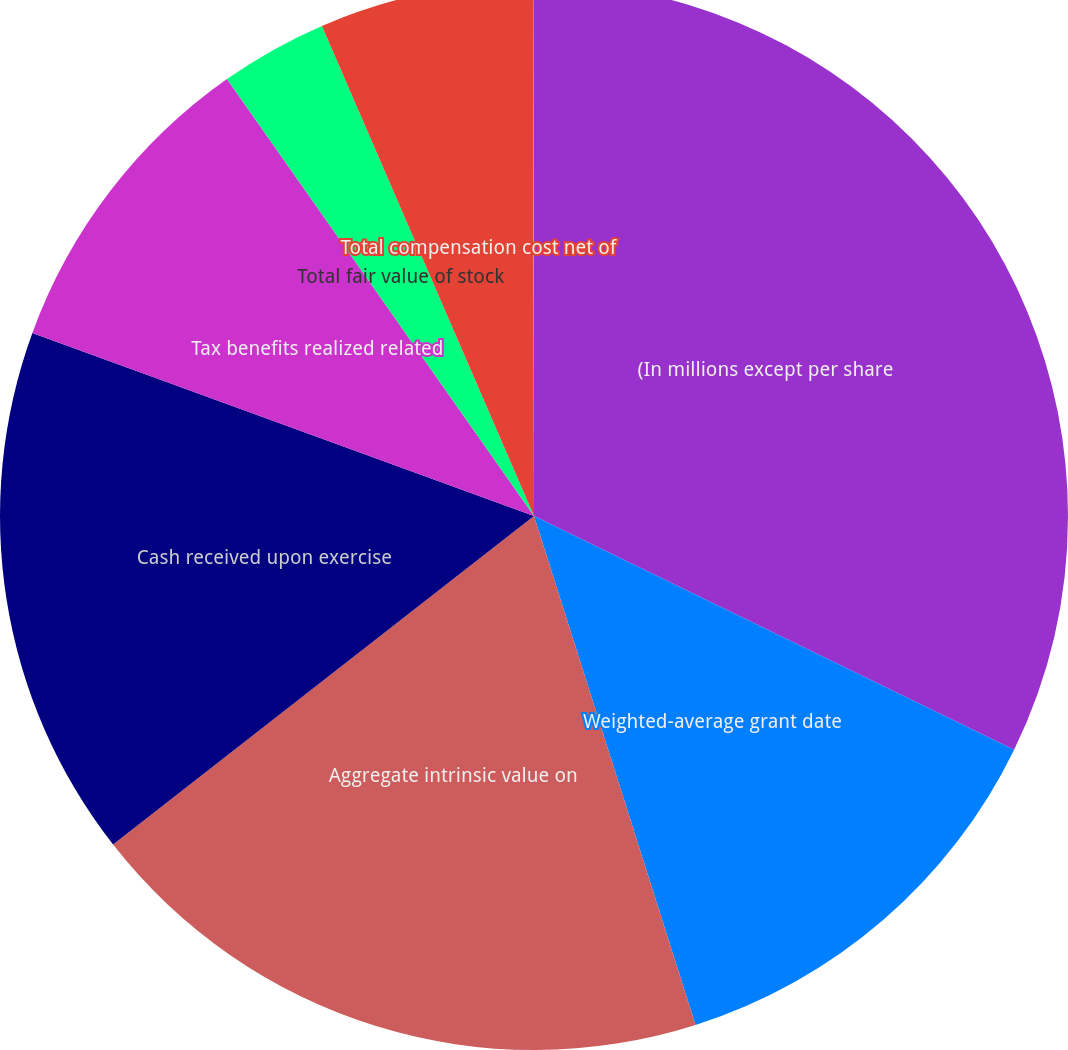<chart> <loc_0><loc_0><loc_500><loc_500><pie_chart><fcel>(In millions except per share<fcel>Weighted-average grant date<fcel>Aggregate intrinsic value on<fcel>Cash received upon exercise<fcel>Tax benefits realized related<fcel>Total fair value of stock<fcel>Total compensation cost net of<fcel>Weighted-average period in<nl><fcel>32.21%<fcel>12.9%<fcel>19.34%<fcel>16.12%<fcel>9.68%<fcel>3.25%<fcel>6.47%<fcel>0.03%<nl></chart> 